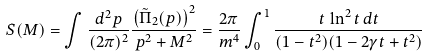<formula> <loc_0><loc_0><loc_500><loc_500>S ( M ) = \int \frac { d ^ { 2 } p } { ( 2 \pi ) ^ { 2 } } \frac { \left ( \tilde { \Pi } _ { 2 } ( p ) \right ) ^ { 2 } } { p ^ { 2 } + M ^ { 2 } } = \frac { 2 \pi } { m ^ { 4 } } \int _ { 0 } ^ { 1 } \frac { t \, \ln ^ { 2 } t \, d t } { ( 1 - t ^ { 2 } ) ( 1 - 2 \gamma t + t ^ { 2 } ) }</formula> 